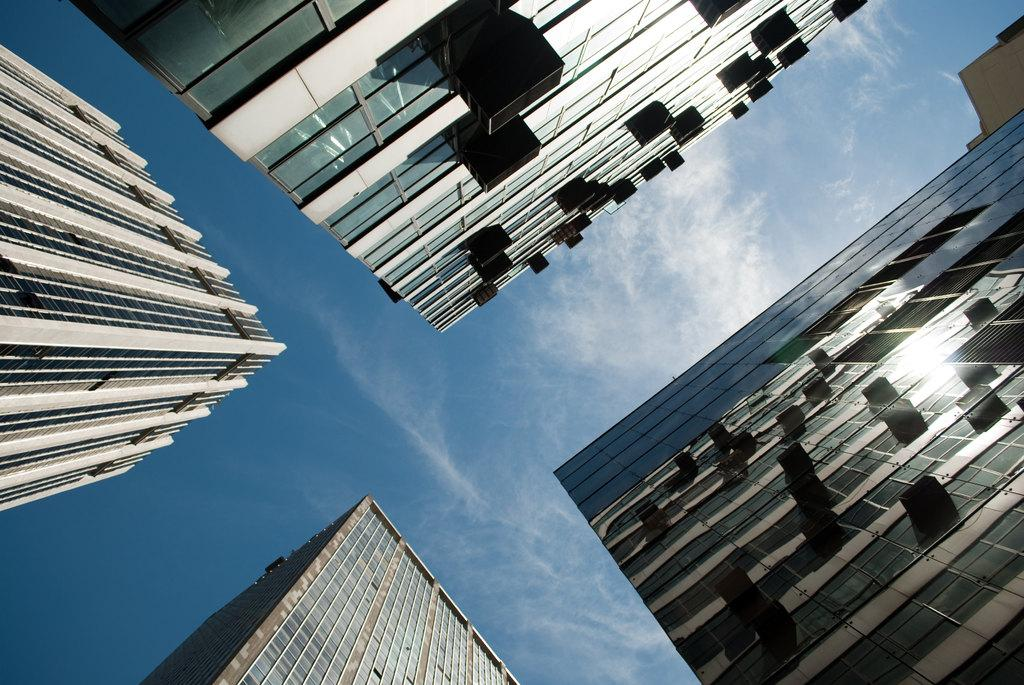What is the main subject of the image? The main subject of the image is many buildings. What can be seen in the background of the image? There are clouds and the sky visible in the background of the image. What type of scarf is draped over the buildings in the image? There is no scarf present in the image; it features many buildings and a background with clouds and the sky. 